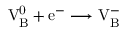<formula> <loc_0><loc_0><loc_500><loc_500>V _ { B } ^ { 0 } + e ^ { - } \longrightarrow V _ { B } ^ { - }</formula> 